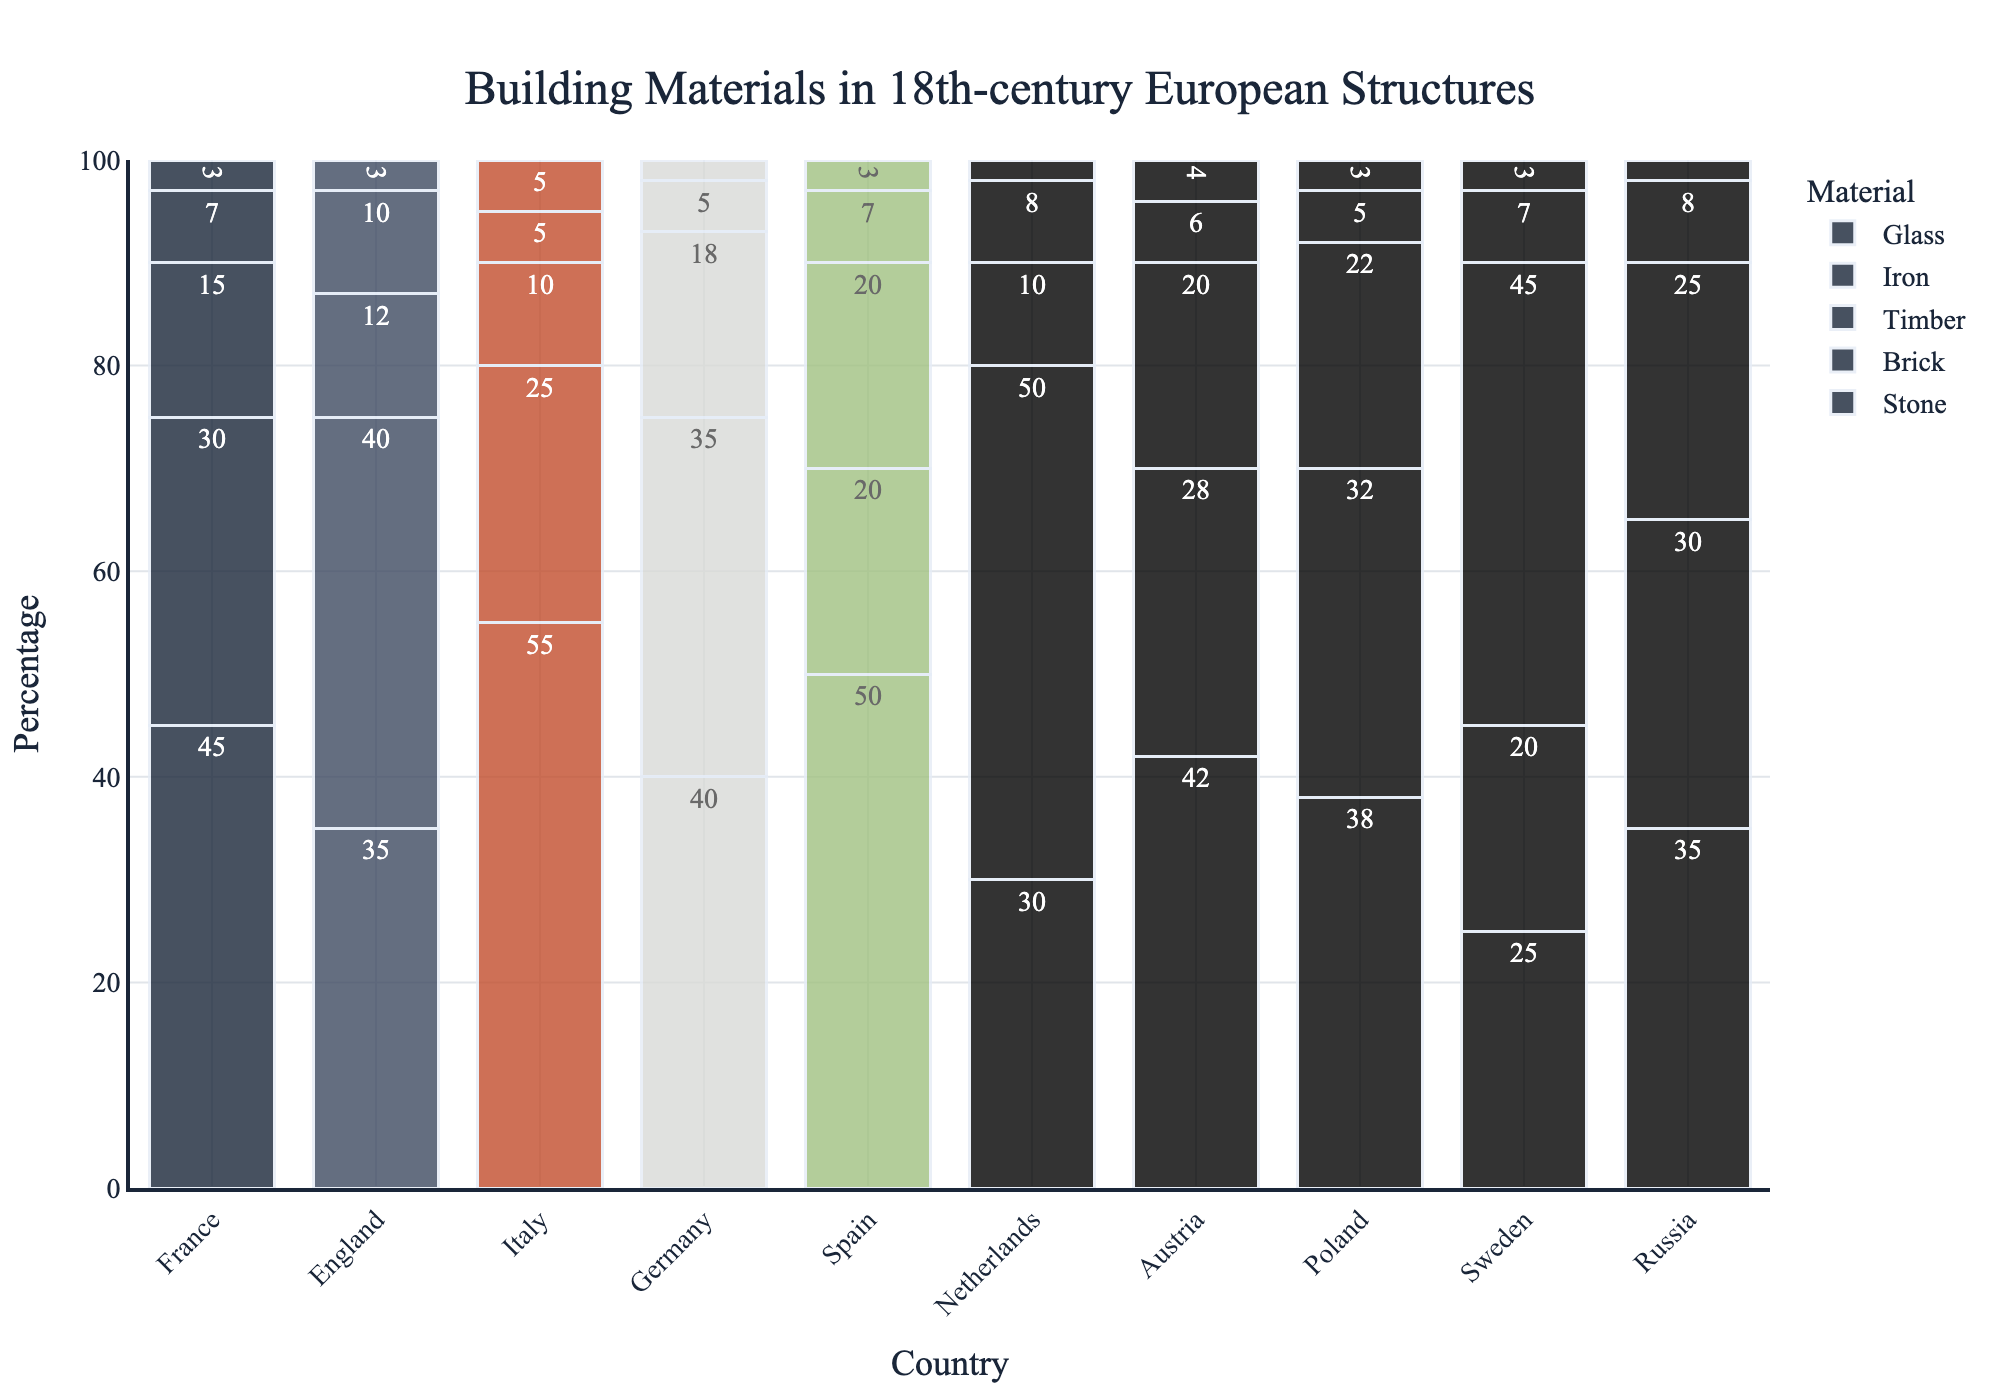What country has the highest use of stone in 18th-century European structures? To find this, examine the height of the stone bars in the bar chart. The country with the tallest stone bar represents the highest stone usage. Italy has the tallest stone bar.
Answer: Italy Which country used brick more than any other material? Check the height comparison of the bars within each country's grouped bars for brick. Netherlands has the tallest brick bar and it is taller compared to its other material bars.
Answer: Netherlands Among Spain, Germany, and Austria, which country has the highest combined percentage of timber and iron usage? Sum the heights of the timber and iron bars for each of these countries. Spain (20+7=27), Germany (18+5=23), and Austria (20+6=26). Spain has the highest combined usage of timber and iron.
Answer: Spain How much more glass does Italy use compared to Germany? Subtract the height of the glass bar for Germany from the height of the glass bar for Italy. Italy (5) - Germany (2) = 3. So Italy uses 3% more glass than Germany.
Answer: 3 Which two countries have the closest percentages for the usage of iron? Compare the iron bar heights for all countries and find the most similar values. England (10) and Russia (8) use iron percentages closest to each other.
Answer: England and Russia What is the average percentage of timber usage across Sweden, Russia, and Poland? Sum the timber usage for these countries and then divide by the number of countries. Sweden (45) + Russia (25) + Poland (22) = 92. The average is 92 / 3 = 30.67.
Answer: 30.67 Which material is used equally by the most number of countries and how many countries use it equally? Identify the material bars across all countries and count how many share the same height. Glass is used equally by the most number of countries – 4 countries (France, England, Spain, and Sweden) each with a usage of 3.
Answer: Glass, 4 countries In which country is the gap between the usage of brick and timber the largest? Calculate the absolute difference between the heights of the brick and timber bars for each country and find the largest difference. Netherlands has the largest gap between brick (50) and timber (10) which is 40.
Answer: Netherlands 